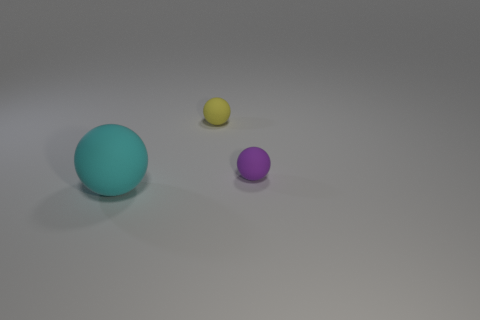Add 3 large red matte cubes. How many objects exist? 6 Subtract all big matte things. Subtract all small brown shiny balls. How many objects are left? 2 Add 2 small things. How many small things are left? 4 Add 3 large cyan objects. How many large cyan objects exist? 4 Subtract 0 blue cylinders. How many objects are left? 3 